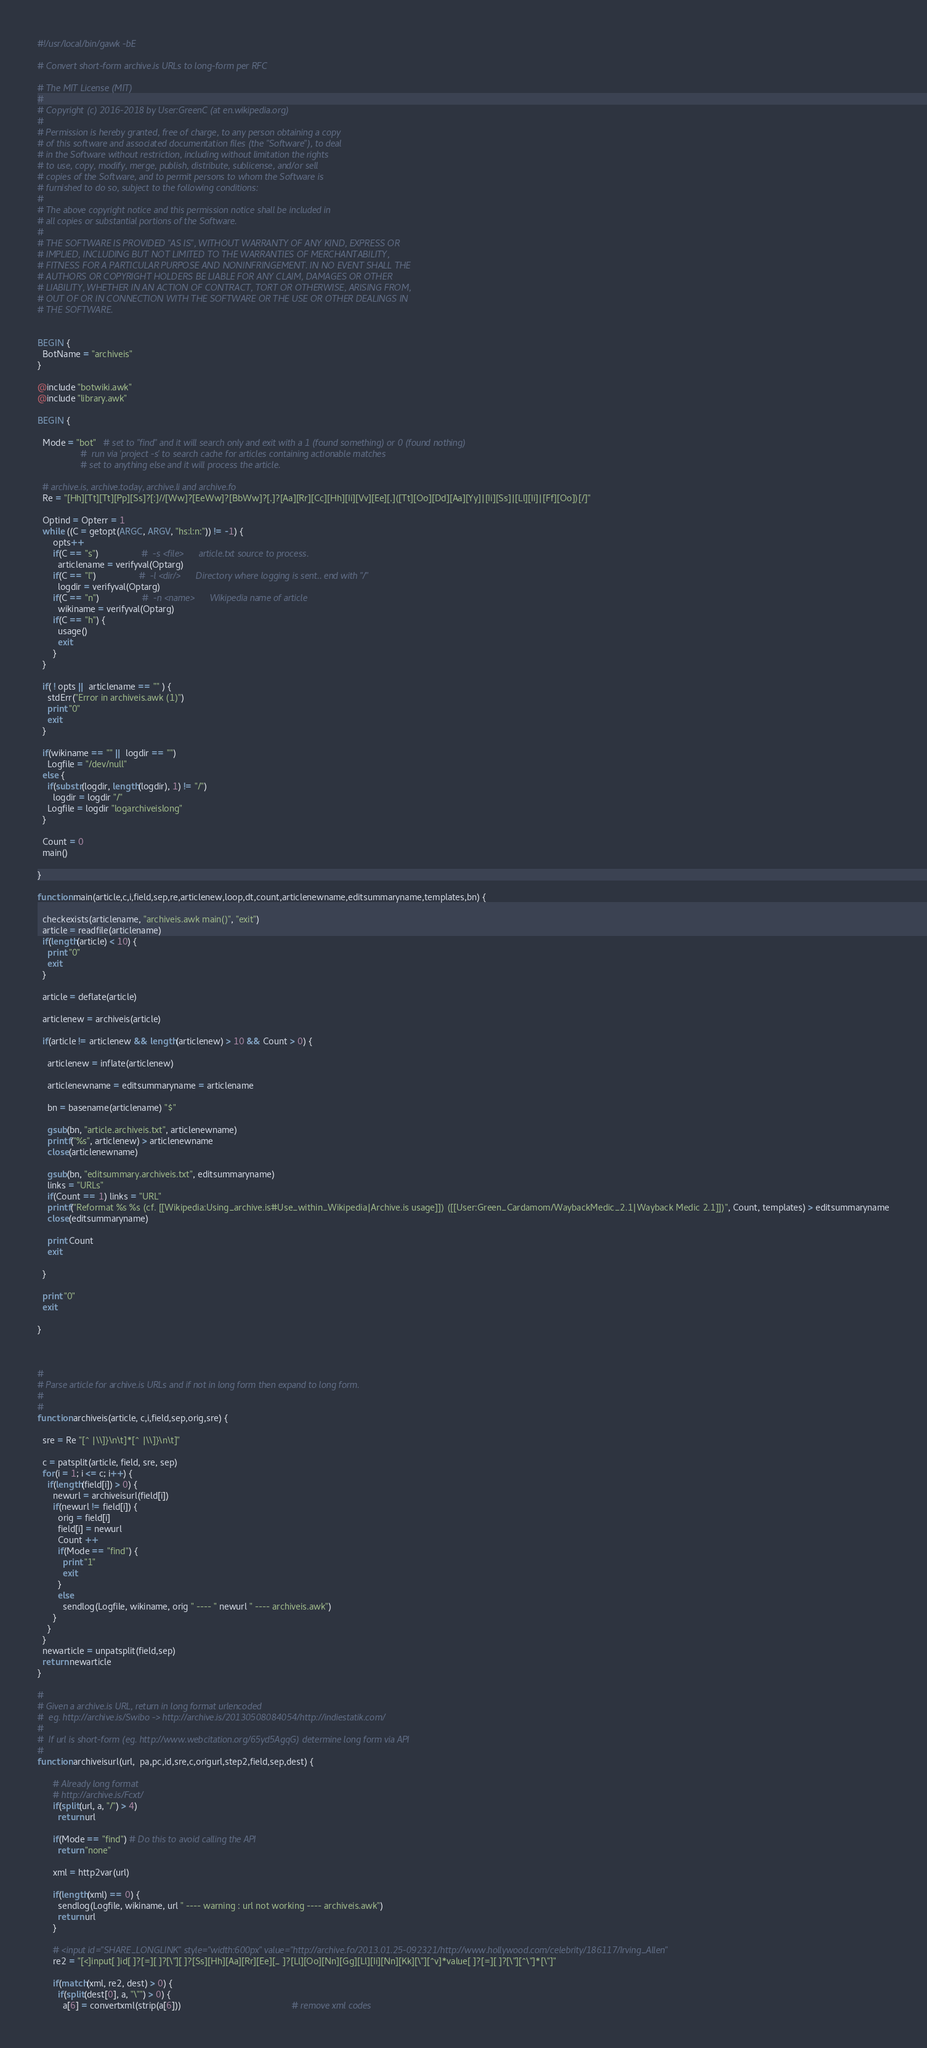Convert code to text. <code><loc_0><loc_0><loc_500><loc_500><_Awk_>#!/usr/local/bin/gawk -bE     

# Convert short-form archive.is URLs to long-form per RFC

# The MIT License (MIT)
#
# Copyright (c) 2016-2018 by User:GreenC (at en.wikipedia.org)
#
# Permission is hereby granted, free of charge, to any person obtaining a copy
# of this software and associated documentation files (the "Software"), to deal
# in the Software without restriction, including without limitation the rights
# to use, copy, modify, merge, publish, distribute, sublicense, and/or sell
# copies of the Software, and to permit persons to whom the Software is
# furnished to do so, subject to the following conditions:
#
# The above copyright notice and this permission notice shall be included in
# all copies or substantial portions of the Software.
#
# THE SOFTWARE IS PROVIDED "AS IS", WITHOUT WARRANTY OF ANY KIND, EXPRESS OR
# IMPLIED, INCLUDING BUT NOT LIMITED TO THE WARRANTIES OF MERCHANTABILITY,
# FITNESS FOR A PARTICULAR PURPOSE AND NONINFRINGEMENT. IN NO EVENT SHALL THE
# AUTHORS OR COPYRIGHT HOLDERS BE LIABLE FOR ANY CLAIM, DAMAGES OR OTHER
# LIABILITY, WHETHER IN AN ACTION OF CONTRACT, TORT OR OTHERWISE, ARISING FROM,
# OUT OF OR IN CONNECTION WITH THE SOFTWARE OR THE USE OR OTHER DEALINGS IN
# THE SOFTWARE.


BEGIN {
  BotName = "archiveis"
}

@include "botwiki.awk"
@include "library.awk"

BEGIN {

  Mode = "bot"   # set to "find" and it will search only and exit with a 1 (found something) or 0 (found nothing)
                 #  run via 'project -s' to search cache for articles containing actionable matches
                 # set to anything else and it will process the article.

  # archive.is, archive.today, archive.li and archive.fo
  Re = "[Hh][Tt][Tt][Pp][Ss]?[:]//[Ww]?[EeWw]?[BbWw]?[.]?[Aa][Rr][Cc][Hh][Ii][Vv][Ee][.]([Tt][Oo][Dd][Aa][Yy]|[Ii][Ss]|[Ll][Ii]|[Ff][Oo])[/]"

  Optind = Opterr = 1
  while ((C = getopt(ARGC, ARGV, "hs:l:n:")) != -1) {
      opts++
      if(C == "s")                 #  -s <file>      article.txt source to process.
        articlename = verifyval(Optarg)
      if(C == "l")                 #  -l <dir/>      Directory where logging is sent.. end with "/"
        logdir = verifyval(Optarg)
      if(C == "n")                 #  -n <name>      Wikipedia name of article
        wikiname = verifyval(Optarg)
      if(C == "h") {
        usage()
        exit
      }
  }

  if( ! opts || articlename == "" ) {
    stdErr("Error in archiveis.awk (1)")
    print "0"
    exit
  }

  if(wikiname == "" || logdir == "")
    Logfile = "/dev/null"
  else {
    if(substr(logdir, length(logdir), 1) != "/")
      logdir = logdir "/"
    Logfile = logdir "logarchiveislong"
  }

  Count = 0
  main()

}

function main(article,c,i,field,sep,re,articlenew,loop,dt,count,articlenewname,editsummaryname,templates,bn) {

  checkexists(articlename, "archiveis.awk main()", "exit")
  article = readfile(articlename)
  if(length(article) < 10) {
    print "0"
    exit
  }

  article = deflate(article)

  articlenew = archiveis(article)

  if(article != articlenew && length(articlenew) > 10 && Count > 0) {

    articlenew = inflate(articlenew)
   
    articlenewname = editsummaryname = articlename

    bn = basename(articlename) "$"

    gsub(bn, "article.archiveis.txt", articlenewname) 
    printf("%s", articlenew) > articlenewname 
    close(articlenewname)

    gsub(bn, "editsummary.archiveis.txt", editsummaryname) 
    links = "URLs"
    if(Count == 1) links = "URL"
    printf("Reformat %s %s (cf. [[Wikipedia:Using_archive.is#Use_within_Wikipedia|Archive.is usage]]) ([[User:Green_Cardamom/WaybackMedic_2.1|Wayback Medic 2.1]])", Count, templates) > editsummaryname
    close(editsummaryname)

    print Count
    exit

  }

  print "0"
  exit

}



#
# Parse article for archive.is URLs and if not in long form then expand to long form.
#
#
function archiveis(article, c,i,field,sep,orig,sre) {

  sre = Re "[^ |\\]}\n\t]*[^ |\\]}\n\t]"

  c = patsplit(article, field, sre, sep)     
  for(i = 1; i <= c; i++) {
    if(length(field[i]) > 0) {
      newurl = archiveisurl(field[i])
      if(newurl != field[i]) {
        orig = field[i]
        field[i] = newurl
        Count ++
        if(Mode == "find") {
          print "1"
          exit
        }
        else 
          sendlog(Logfile, wikiname, orig " ---- " newurl " ---- archiveis.awk")
      }
    }
  }
  newarticle = unpatsplit(field,sep)
  return newarticle
}

#
# Given a archive.is URL, return in long format urlencoded
#  eg. http://archive.is/Swibo -> http://archive.is/20130508084054/http://indiestatik.com/
#
#  If url is short-form (eg. http://www.webcitation.org/65yd5AgqG) determine long form via API
#
function archiveisurl(url,  pa,pc,id,sre,c,origurl,step2,field,sep,dest) {

      # Already long format
      # http://archive.is/Fcxt/
      if(split(url, a, "/") > 4)
        return url

      if(Mode == "find") # Do this to avoid calling the API 
        return "none"

      xml = http2var(url)

      if(length(xml) == 0) {
        sendlog(Logfile, wikiname, url " ---- warning : url not working ---- archiveis.awk")
        return url
      }

      # <input id="SHARE_LONGLINK" style="width:600px" value="http://archive.fo/2013.01.25-092321/http://www.hollywood.com/celebrity/186117/Irving_Allen"
      re2 = "[<]input[ ]id[ ]?[=][ ]?[\"][ ]?[Ss][Hh][Aa][Rr][Ee][_ ]?[Ll][Oo][Nn][Gg][Ll][Ii][Nn][Kk][\"][^v]*value[ ]?[=][ ]?[\"][^\"]*[\"]"

      if(match(xml, re2, dest) > 0) {
        if(split(dest[0], a, "\"") > 0) {
          a[6] = convertxml(strip(a[6]))                                            # remove xml codes</code> 